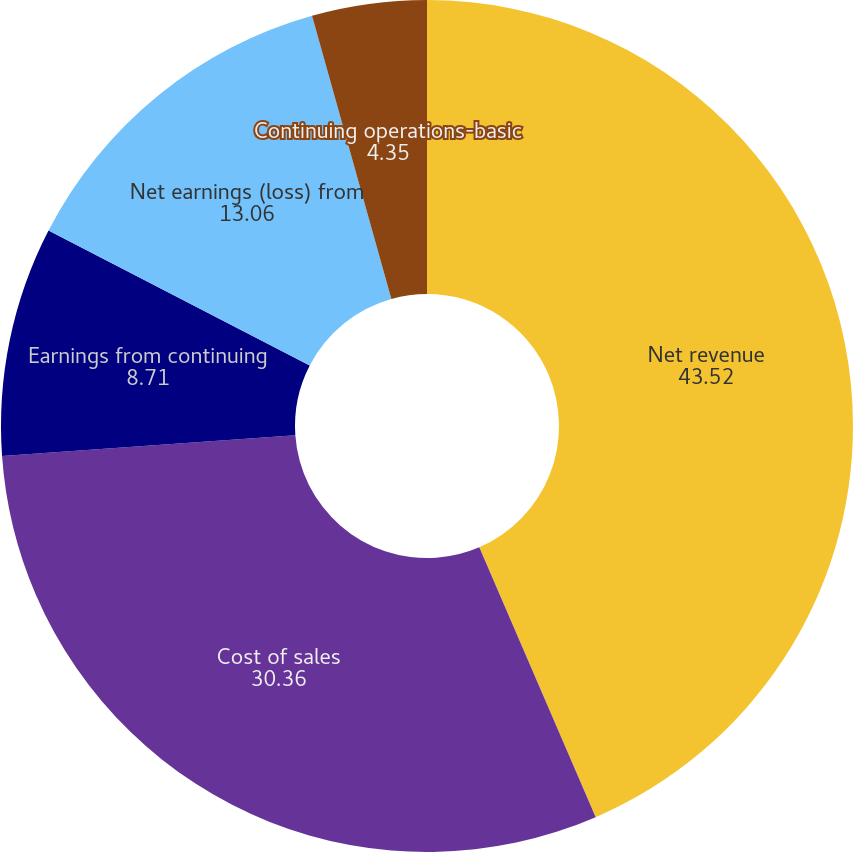Convert chart. <chart><loc_0><loc_0><loc_500><loc_500><pie_chart><fcel>Net revenue<fcel>Cost of sales<fcel>Earnings from continuing<fcel>Net earnings (loss) from<fcel>Continuing operations-basic<fcel>Continuing operations-diluted<nl><fcel>43.52%<fcel>30.36%<fcel>8.71%<fcel>13.06%<fcel>4.35%<fcel>0.0%<nl></chart> 